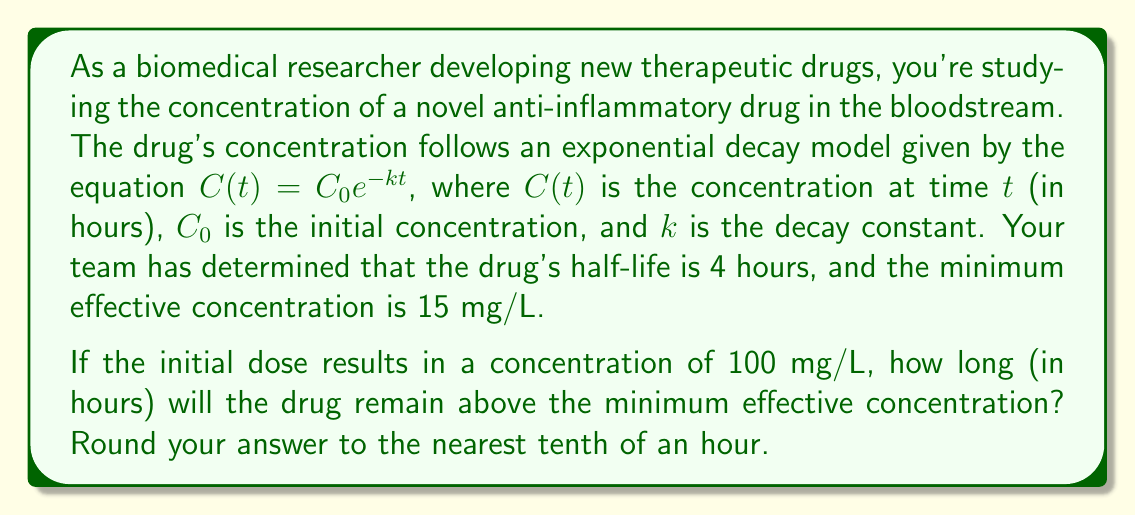Solve this math problem. To solve this problem, we'll follow these steps:

1) First, we need to determine the decay constant $k$ using the half-life information:

   Half-life $t_{1/2} = 4$ hours
   At half-life, $C(t_{1/2}) = \frac{1}{2}C_0$

   Substituting into the decay equation:
   $$\frac{1}{2}C_0 = C_0e^{-k(4)}$$

   Simplifying:
   $$\frac{1}{2} = e^{-4k}$$

   Taking natural log of both sides:
   $$\ln(\frac{1}{2}) = -4k$$

   $$k = \frac{\ln(2)}{4} \approx 0.1733$$

2) Now we can use the exponential decay equation to find when the concentration reaches 15 mg/L:

   $$15 = 100e^{-0.1733t}$$

3) Solving for $t$:

   $$\frac{15}{100} = e^{-0.1733t}$$

   $$\ln(\frac{15}{100}) = -0.1733t$$

   $$t = \frac{\ln(\frac{15}{100})}{-0.1733} \approx 11.5$$

4) Rounding to the nearest tenth:

   $t \approx 11.5$ hours
Answer: 11.5 hours 